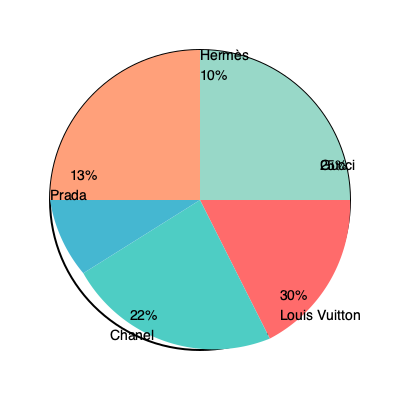Based on the market share data presented in the pie chart, which two luxury fashion brands collectively account for 55% of the market, and what strategic implications might this have for a fashion merchandiser looking to optimize inventory and partnerships? To answer this question, we need to follow these steps:

1. Identify the two brands with the largest market shares:
   - Louis Vuitton: 30%
   - Gucci: 25%

2. Calculate their combined market share:
   $30\% + 25\% = 55\%$

3. Consider the strategic implications for a fashion merchandiser:

   a) Inventory Management:
      - Allocate more space and resources to Louis Vuitton and Gucci products
      - Ensure a diverse range of products from these brands to meet demand
      - Consider limited stock for other brands to minimize risk

   b) Partnerships and Negotiations:
      - Prioritize strong relationships with Louis Vuitton and Gucci
      - Negotiate better terms, such as exclusive deals or early access to new collections
      - Leverage the combined 55% market share to gain bargaining power

   c) Customer Focus:
      - Develop marketing strategies targeting Louis Vuitton and Gucci customers
      - Create cross-selling opportunities between these two brands
      - Analyze the customer overlap between the two brands for personalized marketing

   d) Trend Analysis:
      - Closely monitor Louis Vuitton and Gucci's product trends and innovations
      - Use insights from these brands to inform decisions about other luxury brands

   e) Risk Management:
      - While focusing on the top two brands, maintain relationships with other brands
      - Diversify portfolio to some extent to mitigate risks associated with overreliance on two brands

   f) Growth Opportunities:
      - Identify gaps in the market that Louis Vuitton and Gucci might not be addressing
      - Consider opportunities with emerging brands that could disrupt the market

By focusing on these two dominant brands while maintaining a strategic approach to the overall luxury fashion market, a merchandiser can optimize inventory, strengthen key partnerships, and position themselves for success in the competitive luxury retail landscape.
Answer: Louis Vuitton and Gucci; optimize inventory for these brands, strengthen partnerships, focus marketing, and balance with diversification strategies. 